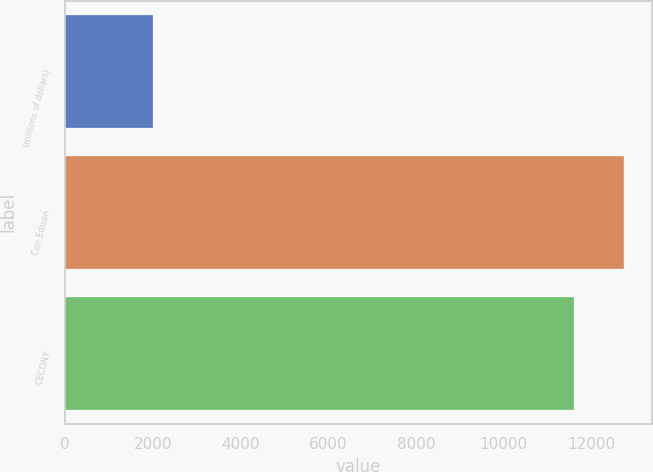Convert chart to OTSL. <chart><loc_0><loc_0><loc_500><loc_500><bar_chart><fcel>(millions of dollars)<fcel>Con Edison<fcel>CECONY<nl><fcel>2011<fcel>12744<fcel>11593<nl></chart> 